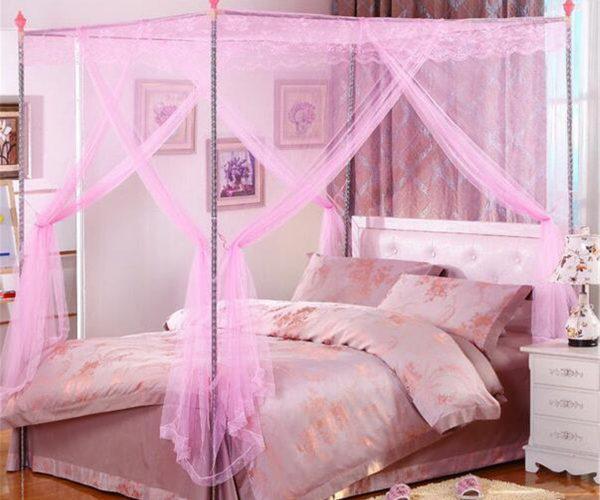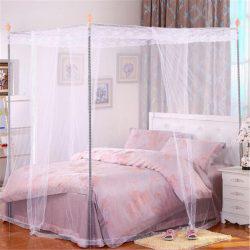The first image is the image on the left, the second image is the image on the right. For the images displayed, is the sentence "The bed on the left has a canopy that ties at the middle of the four posts, and the bed on the right has a pale canopy that creates a square shape but does not tie at the corners." factually correct? Answer yes or no. Yes. The first image is the image on the left, the second image is the image on the right. Evaluate the accuracy of this statement regarding the images: "The left and right image contains the same number of square lace canopies.". Is it true? Answer yes or no. Yes. 